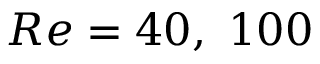<formula> <loc_0><loc_0><loc_500><loc_500>R e = 4 0 , \ 1 0 0</formula> 